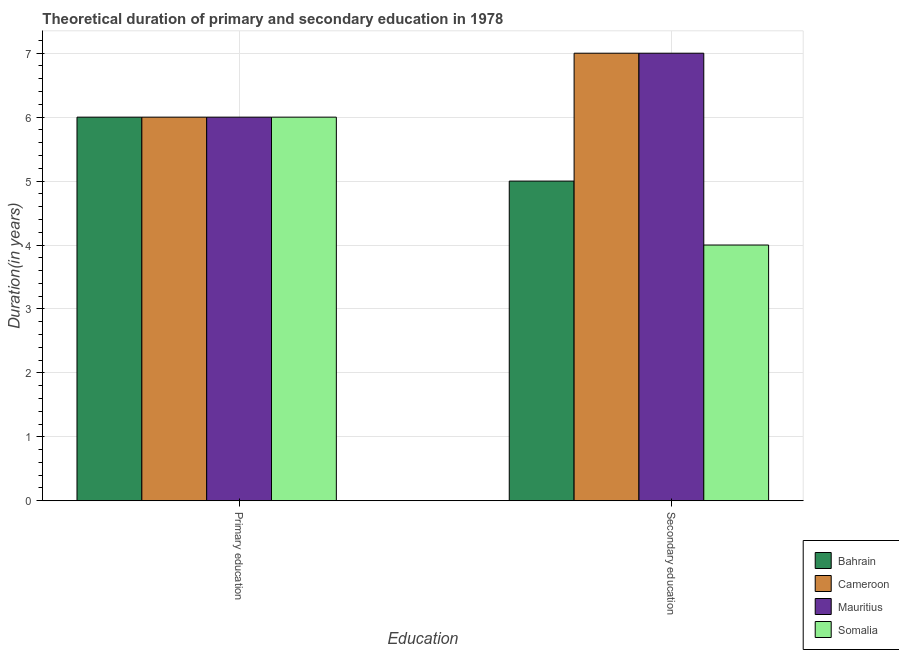How many different coloured bars are there?
Provide a short and direct response. 4. How many groups of bars are there?
Offer a very short reply. 2. Are the number of bars per tick equal to the number of legend labels?
Your answer should be compact. Yes. Are the number of bars on each tick of the X-axis equal?
Provide a succinct answer. Yes. How many bars are there on the 2nd tick from the left?
Your answer should be very brief. 4. How many bars are there on the 1st tick from the right?
Make the answer very short. 4. What is the label of the 1st group of bars from the left?
Your response must be concise. Primary education. What is the duration of secondary education in Bahrain?
Your answer should be compact. 5. Across all countries, what is the maximum duration of primary education?
Provide a succinct answer. 6. In which country was the duration of primary education maximum?
Ensure brevity in your answer.  Bahrain. In which country was the duration of primary education minimum?
Provide a succinct answer. Bahrain. What is the total duration of primary education in the graph?
Make the answer very short. 24. What is the difference between the duration of secondary education in Bahrain and that in Cameroon?
Your answer should be compact. -2. What is the difference between the duration of secondary education in Mauritius and the duration of primary education in Somalia?
Provide a succinct answer. 1. What is the average duration of secondary education per country?
Your answer should be compact. 5.75. What is the difference between the duration of primary education and duration of secondary education in Bahrain?
Offer a terse response. 1. What is the ratio of the duration of primary education in Cameroon to that in Bahrain?
Ensure brevity in your answer.  1. What does the 2nd bar from the left in Primary education represents?
Keep it short and to the point. Cameroon. What does the 4th bar from the right in Secondary education represents?
Provide a short and direct response. Bahrain. Are all the bars in the graph horizontal?
Your answer should be very brief. No. Does the graph contain any zero values?
Your response must be concise. No. Where does the legend appear in the graph?
Offer a terse response. Bottom right. How many legend labels are there?
Provide a short and direct response. 4. What is the title of the graph?
Provide a short and direct response. Theoretical duration of primary and secondary education in 1978. What is the label or title of the X-axis?
Provide a succinct answer. Education. What is the label or title of the Y-axis?
Give a very brief answer. Duration(in years). What is the Duration(in years) in Bahrain in Primary education?
Offer a terse response. 6. What is the Duration(in years) in Bahrain in Secondary education?
Provide a succinct answer. 5. What is the Duration(in years) of Mauritius in Secondary education?
Offer a terse response. 7. What is the Duration(in years) of Somalia in Secondary education?
Give a very brief answer. 4. Across all Education, what is the maximum Duration(in years) in Bahrain?
Your response must be concise. 6. Across all Education, what is the minimum Duration(in years) in Bahrain?
Offer a terse response. 5. Across all Education, what is the minimum Duration(in years) in Cameroon?
Ensure brevity in your answer.  6. Across all Education, what is the minimum Duration(in years) in Mauritius?
Keep it short and to the point. 6. Across all Education, what is the minimum Duration(in years) of Somalia?
Give a very brief answer. 4. What is the total Duration(in years) of Cameroon in the graph?
Give a very brief answer. 13. What is the total Duration(in years) in Mauritius in the graph?
Offer a terse response. 13. What is the difference between the Duration(in years) in Somalia in Primary education and that in Secondary education?
Offer a terse response. 2. What is the difference between the Duration(in years) in Bahrain in Primary education and the Duration(in years) in Somalia in Secondary education?
Your response must be concise. 2. What is the difference between the Duration(in years) in Bahrain and Duration(in years) in Cameroon in Primary education?
Your answer should be compact. 0. What is the difference between the Duration(in years) in Bahrain and Duration(in years) in Mauritius in Primary education?
Your answer should be very brief. 0. What is the difference between the Duration(in years) of Bahrain and Duration(in years) of Cameroon in Secondary education?
Your answer should be very brief. -2. What is the difference between the Duration(in years) in Bahrain and Duration(in years) in Mauritius in Secondary education?
Offer a very short reply. -2. What is the difference between the Duration(in years) of Cameroon and Duration(in years) of Somalia in Secondary education?
Make the answer very short. 3. What is the difference between the Duration(in years) in Mauritius and Duration(in years) in Somalia in Secondary education?
Offer a terse response. 3. What is the ratio of the Duration(in years) in Somalia in Primary education to that in Secondary education?
Provide a short and direct response. 1.5. What is the difference between the highest and the second highest Duration(in years) of Somalia?
Offer a terse response. 2. What is the difference between the highest and the lowest Duration(in years) of Cameroon?
Offer a very short reply. 1. What is the difference between the highest and the lowest Duration(in years) of Somalia?
Provide a succinct answer. 2. 